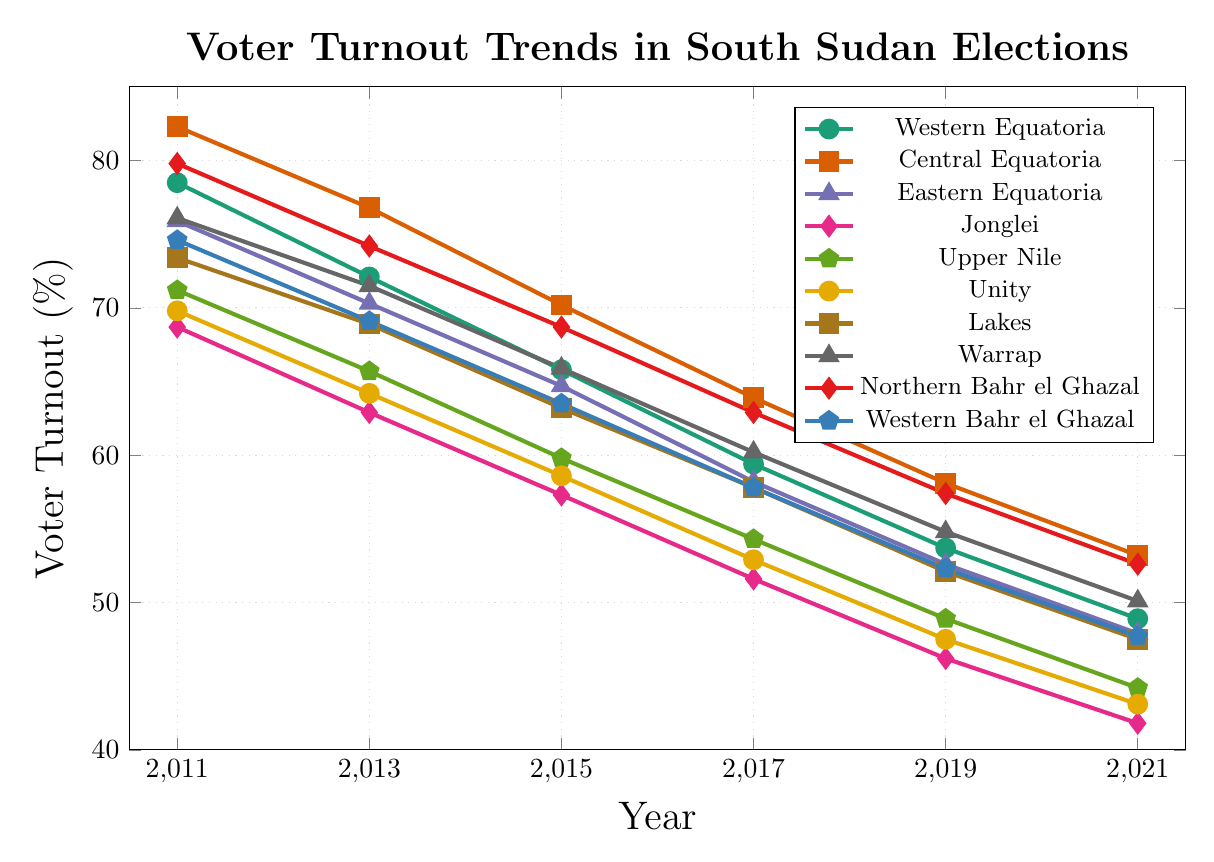What is the overall trend in voter turnout for Western Equatoria from 2011 to 2021? The voter turnout rate for Western Equatoria consistently declines over the years from 78.5% in 2011 to 48.9% in 2021.
Answer: Decline Which region had the highest voter turnout in 2011, and what was the percentage? By looking at the 2011 data points, Central Equatoria had the highest voter turnout at 82.3%.
Answer: Central Equatoria, 82.3% How many regions had voter turnout above 70% in 2013? Based on the 2013 data points, Western Equatoria, Central Equatoria, Eastern Equatoria, Lakes, Warrap, and Northern Bahr el Ghazal had voter turnout rates above 70%.
Answer: 6 regions Which region experienced the largest decrease in voter turnout percentage between 2011 and 2021? Calculating the differences, Central Equatoria decreased from 82.3% to 53.2%, a decrease of 29.1%. Jonglei decreased from 68.7% to 41.8%, a decrease of 26.9%. The largest decrease was in Central Equatoria.
Answer: Central Equatoria Compare the voter turnout rates between Central Equatoria and Unity in 2021. Which region had a higher rate and by how much? In 2021, Central Equatoria had a voter turnout rate of 53.2%, and Unity had 43.1%. Central Equatoria had a higher rate by 10.1%.
Answer: Central Equatoria by 10.1% What is the average voter turnout for Northern Bahr el Ghazal across all years? Sum of voter turnout rates for Northern Bahr el Ghazal across all years: (79.8 + 74.2 + 68.7 + 62.9 + 57.4 + 52.6) = 395.6. Dividing by the number of years (6) gives an average of 65.93%.
Answer: 65.93% Which region showed the smallest decrease in voter turnout from 2017 to 2019? Calculating the differences between 2017 and 2019, Jonglei had a decrease from 51.6% to 46.2%, which is 5.4%. Other regions had larger differences, so Jonglei had the smallest decrease.
Answer: Jonglei What is the difference in voter turnout between the region with the highest and lowest turnout in 2021? In 2021, Central Equatoria had the highest turnout at 53.2% and Jonglei had the lowest at 41.8%. The difference is 53.2% - 41.8% = 11.4%.
Answer: 11.4% What is the median voter turnout for Western Bahr el Ghazal from 2011 to 2021? The data points for Western Bahr el Ghazal from 2011 to 2021 are 74.6, 69.1, 63.5, 57.8, 52.3, 47.7. Ordering them: 47.7, 52.3, 57.8, 63.5, 69.1, 74.6. The median is (57.8 + 63.5)/2 = 60.65%.
Answer: 60.65% Which regions' voter turnout remained above 50% throughout the observed period? Checking all the regions' data from 2011 to 2021, only Northern Bahr el Ghazal and Central Equatoria remained above 50% throughout the period.
Answer: Northern Bahr el Ghazal, Central Equatoria 